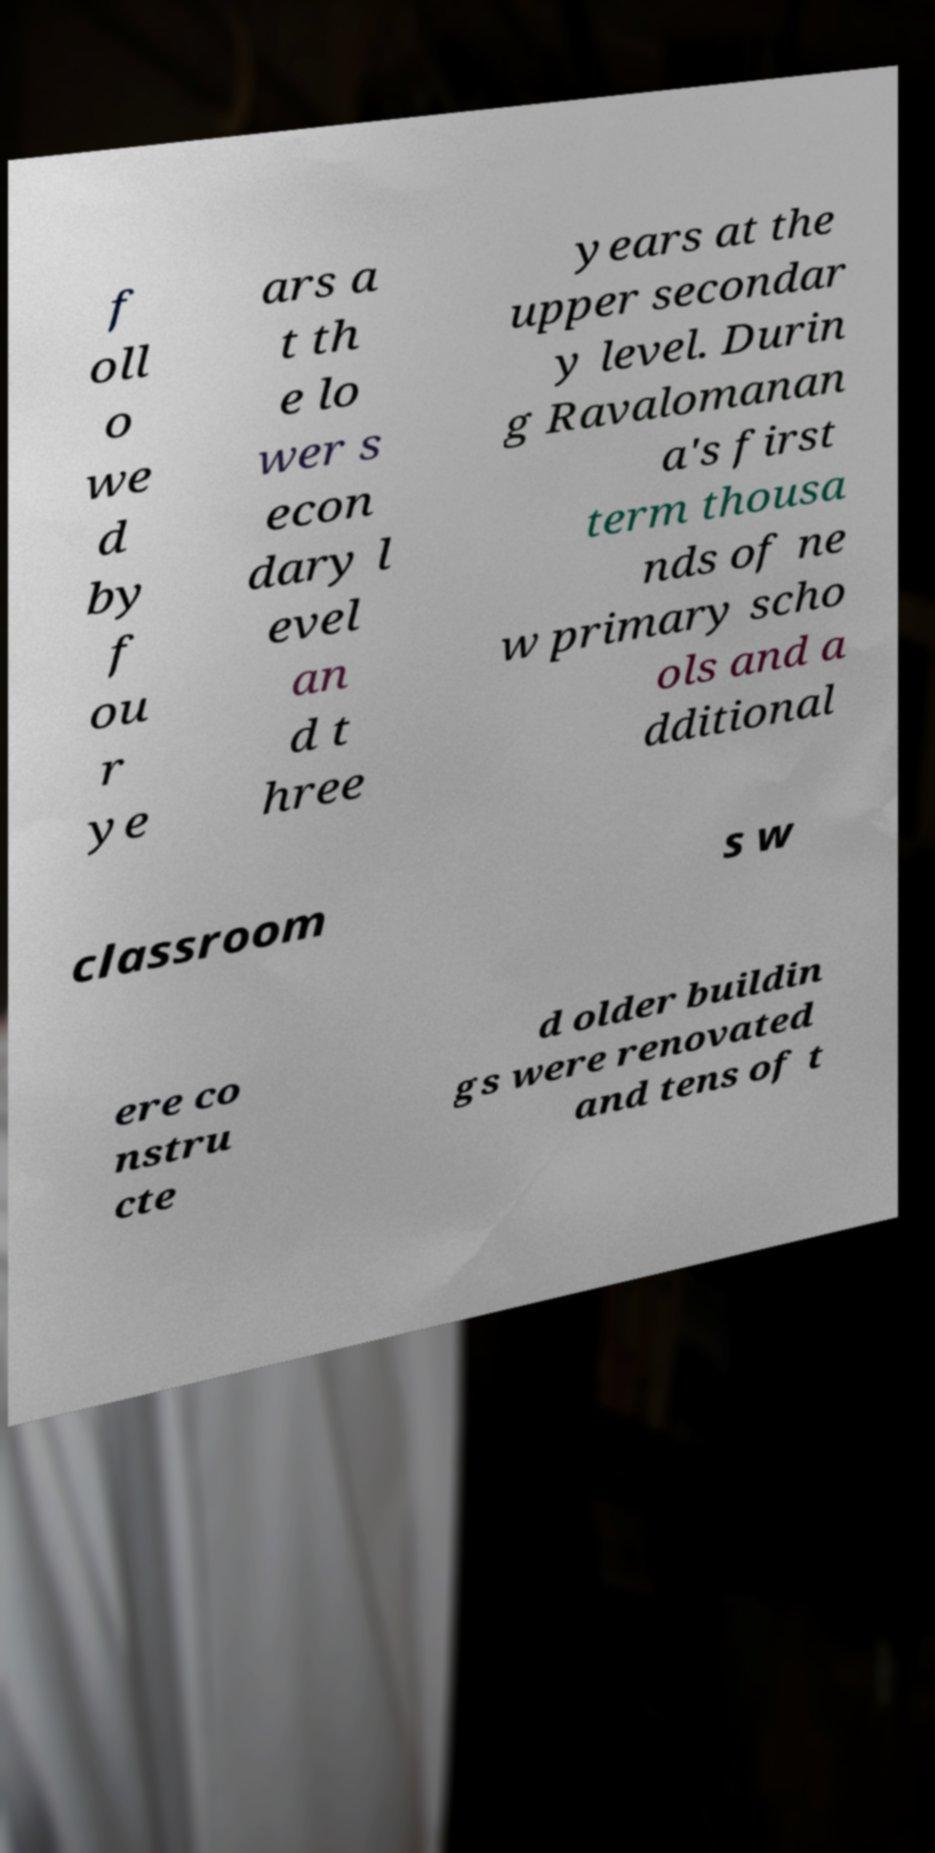There's text embedded in this image that I need extracted. Can you transcribe it verbatim? f oll o we d by f ou r ye ars a t th e lo wer s econ dary l evel an d t hree years at the upper secondar y level. Durin g Ravalomanan a's first term thousa nds of ne w primary scho ols and a dditional classroom s w ere co nstru cte d older buildin gs were renovated and tens of t 